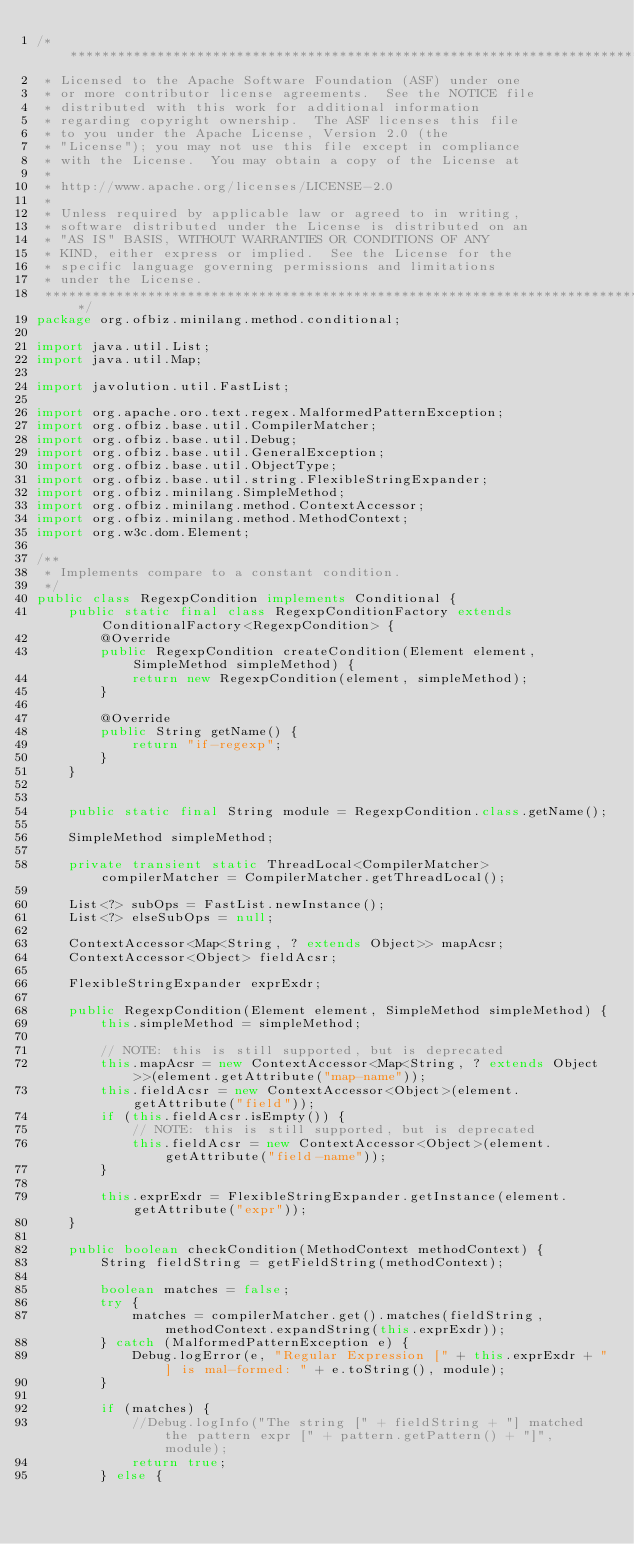Convert code to text. <code><loc_0><loc_0><loc_500><loc_500><_Java_>/*******************************************************************************
 * Licensed to the Apache Software Foundation (ASF) under one
 * or more contributor license agreements.  See the NOTICE file
 * distributed with this work for additional information
 * regarding copyright ownership.  The ASF licenses this file
 * to you under the Apache License, Version 2.0 (the
 * "License"); you may not use this file except in compliance
 * with the License.  You may obtain a copy of the License at
 *
 * http://www.apache.org/licenses/LICENSE-2.0
 *
 * Unless required by applicable law or agreed to in writing,
 * software distributed under the License is distributed on an
 * "AS IS" BASIS, WITHOUT WARRANTIES OR CONDITIONS OF ANY
 * KIND, either express or implied.  See the License for the
 * specific language governing permissions and limitations
 * under the License.
 *******************************************************************************/
package org.ofbiz.minilang.method.conditional;

import java.util.List;
import java.util.Map;

import javolution.util.FastList;

import org.apache.oro.text.regex.MalformedPatternException;
import org.ofbiz.base.util.CompilerMatcher;
import org.ofbiz.base.util.Debug;
import org.ofbiz.base.util.GeneralException;
import org.ofbiz.base.util.ObjectType;
import org.ofbiz.base.util.string.FlexibleStringExpander;
import org.ofbiz.minilang.SimpleMethod;
import org.ofbiz.minilang.method.ContextAccessor;
import org.ofbiz.minilang.method.MethodContext;
import org.w3c.dom.Element;

/**
 * Implements compare to a constant condition.
 */
public class RegexpCondition implements Conditional {
    public static final class RegexpConditionFactory extends ConditionalFactory<RegexpCondition> {
        @Override
        public RegexpCondition createCondition(Element element, SimpleMethod simpleMethod) {
            return new RegexpCondition(element, simpleMethod);
        }

        @Override
        public String getName() {
            return "if-regexp";
        }
    }


    public static final String module = RegexpCondition.class.getName();

    SimpleMethod simpleMethod;

    private transient static ThreadLocal<CompilerMatcher> compilerMatcher = CompilerMatcher.getThreadLocal();

    List<?> subOps = FastList.newInstance();
    List<?> elseSubOps = null;

    ContextAccessor<Map<String, ? extends Object>> mapAcsr;
    ContextAccessor<Object> fieldAcsr;

    FlexibleStringExpander exprExdr;

    public RegexpCondition(Element element, SimpleMethod simpleMethod) {
        this.simpleMethod = simpleMethod;

        // NOTE: this is still supported, but is deprecated
        this.mapAcsr = new ContextAccessor<Map<String, ? extends Object>>(element.getAttribute("map-name"));
        this.fieldAcsr = new ContextAccessor<Object>(element.getAttribute("field"));
        if (this.fieldAcsr.isEmpty()) {
            // NOTE: this is still supported, but is deprecated
            this.fieldAcsr = new ContextAccessor<Object>(element.getAttribute("field-name"));
        }

        this.exprExdr = FlexibleStringExpander.getInstance(element.getAttribute("expr"));
    }

    public boolean checkCondition(MethodContext methodContext) {
        String fieldString = getFieldString(methodContext);

        boolean matches = false;
        try {
            matches = compilerMatcher.get().matches(fieldString, methodContext.expandString(this.exprExdr));
        } catch (MalformedPatternException e) {
            Debug.logError(e, "Regular Expression [" + this.exprExdr + "] is mal-formed: " + e.toString(), module);
        }

        if (matches) {
            //Debug.logInfo("The string [" + fieldString + "] matched the pattern expr [" + pattern.getPattern() + "]", module);
            return true;
        } else {</code> 